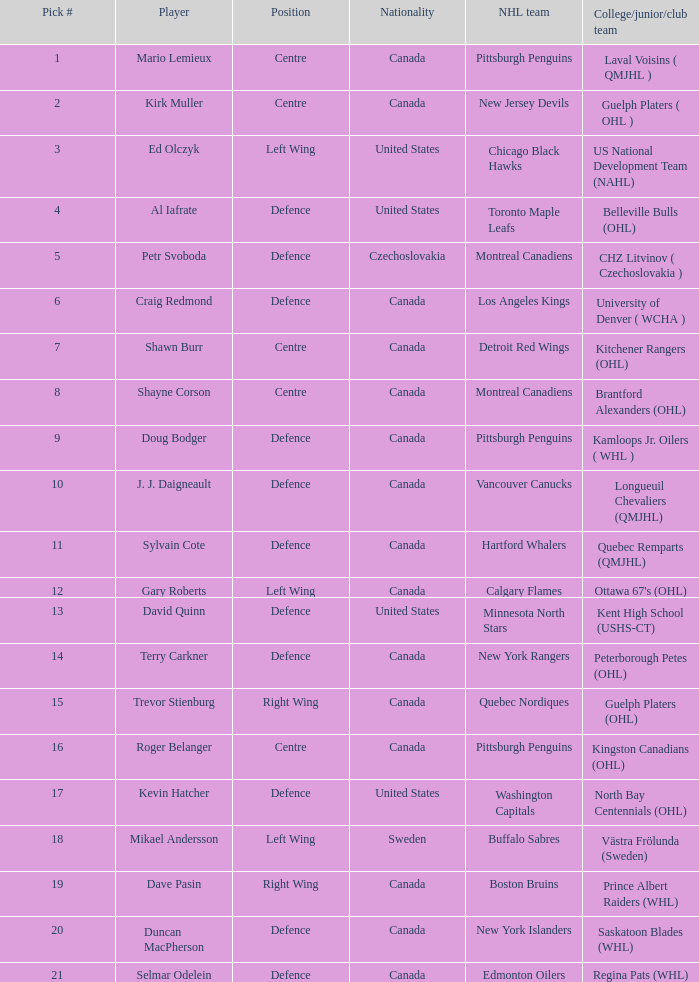What player is draft pick 17? Kevin Hatcher. Help me parse the entirety of this table. {'header': ['Pick #', 'Player', 'Position', 'Nationality', 'NHL team', 'College/junior/club team'], 'rows': [['1', 'Mario Lemieux', 'Centre', 'Canada', 'Pittsburgh Penguins', 'Laval Voisins ( QMJHL )'], ['2', 'Kirk Muller', 'Centre', 'Canada', 'New Jersey Devils', 'Guelph Platers ( OHL )'], ['3', 'Ed Olczyk', 'Left Wing', 'United States', 'Chicago Black Hawks', 'US National Development Team (NAHL)'], ['4', 'Al Iafrate', 'Defence', 'United States', 'Toronto Maple Leafs', 'Belleville Bulls (OHL)'], ['5', 'Petr Svoboda', 'Defence', 'Czechoslovakia', 'Montreal Canadiens', 'CHZ Litvinov ( Czechoslovakia )'], ['6', 'Craig Redmond', 'Defence', 'Canada', 'Los Angeles Kings', 'University of Denver ( WCHA )'], ['7', 'Shawn Burr', 'Centre', 'Canada', 'Detroit Red Wings', 'Kitchener Rangers (OHL)'], ['8', 'Shayne Corson', 'Centre', 'Canada', 'Montreal Canadiens', 'Brantford Alexanders (OHL)'], ['9', 'Doug Bodger', 'Defence', 'Canada', 'Pittsburgh Penguins', 'Kamloops Jr. Oilers ( WHL )'], ['10', 'J. J. Daigneault', 'Defence', 'Canada', 'Vancouver Canucks', 'Longueuil Chevaliers (QMJHL)'], ['11', 'Sylvain Cote', 'Defence', 'Canada', 'Hartford Whalers', 'Quebec Remparts (QMJHL)'], ['12', 'Gary Roberts', 'Left Wing', 'Canada', 'Calgary Flames', "Ottawa 67's (OHL)"], ['13', 'David Quinn', 'Defence', 'United States', 'Minnesota North Stars', 'Kent High School (USHS-CT)'], ['14', 'Terry Carkner', 'Defence', 'Canada', 'New York Rangers', 'Peterborough Petes (OHL)'], ['15', 'Trevor Stienburg', 'Right Wing', 'Canada', 'Quebec Nordiques', 'Guelph Platers (OHL)'], ['16', 'Roger Belanger', 'Centre', 'Canada', 'Pittsburgh Penguins', 'Kingston Canadians (OHL)'], ['17', 'Kevin Hatcher', 'Defence', 'United States', 'Washington Capitals', 'North Bay Centennials (OHL)'], ['18', 'Mikael Andersson', 'Left Wing', 'Sweden', 'Buffalo Sabres', 'Västra Frölunda (Sweden)'], ['19', 'Dave Pasin', 'Right Wing', 'Canada', 'Boston Bruins', 'Prince Albert Raiders (WHL)'], ['20', 'Duncan MacPherson', 'Defence', 'Canada', 'New York Islanders', 'Saskatoon Blades (WHL)'], ['21', 'Selmar Odelein', 'Defence', 'Canada', 'Edmonton Oilers', 'Regina Pats (WHL)']]} 